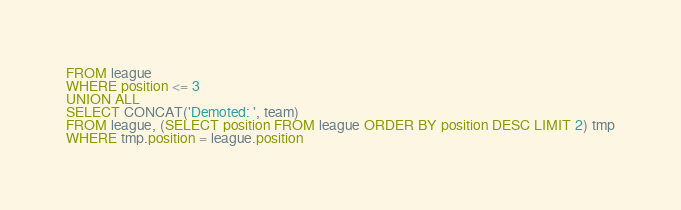Convert code to text. <code><loc_0><loc_0><loc_500><loc_500><_SQL_>FROM league
WHERE position <= 3
UNION ALL
SELECT CONCAT('Demoted: ', team)
FROM league, (SELECT position FROM league ORDER BY position DESC LIMIT 2) tmp
WHERE tmp.position = league.position</code> 